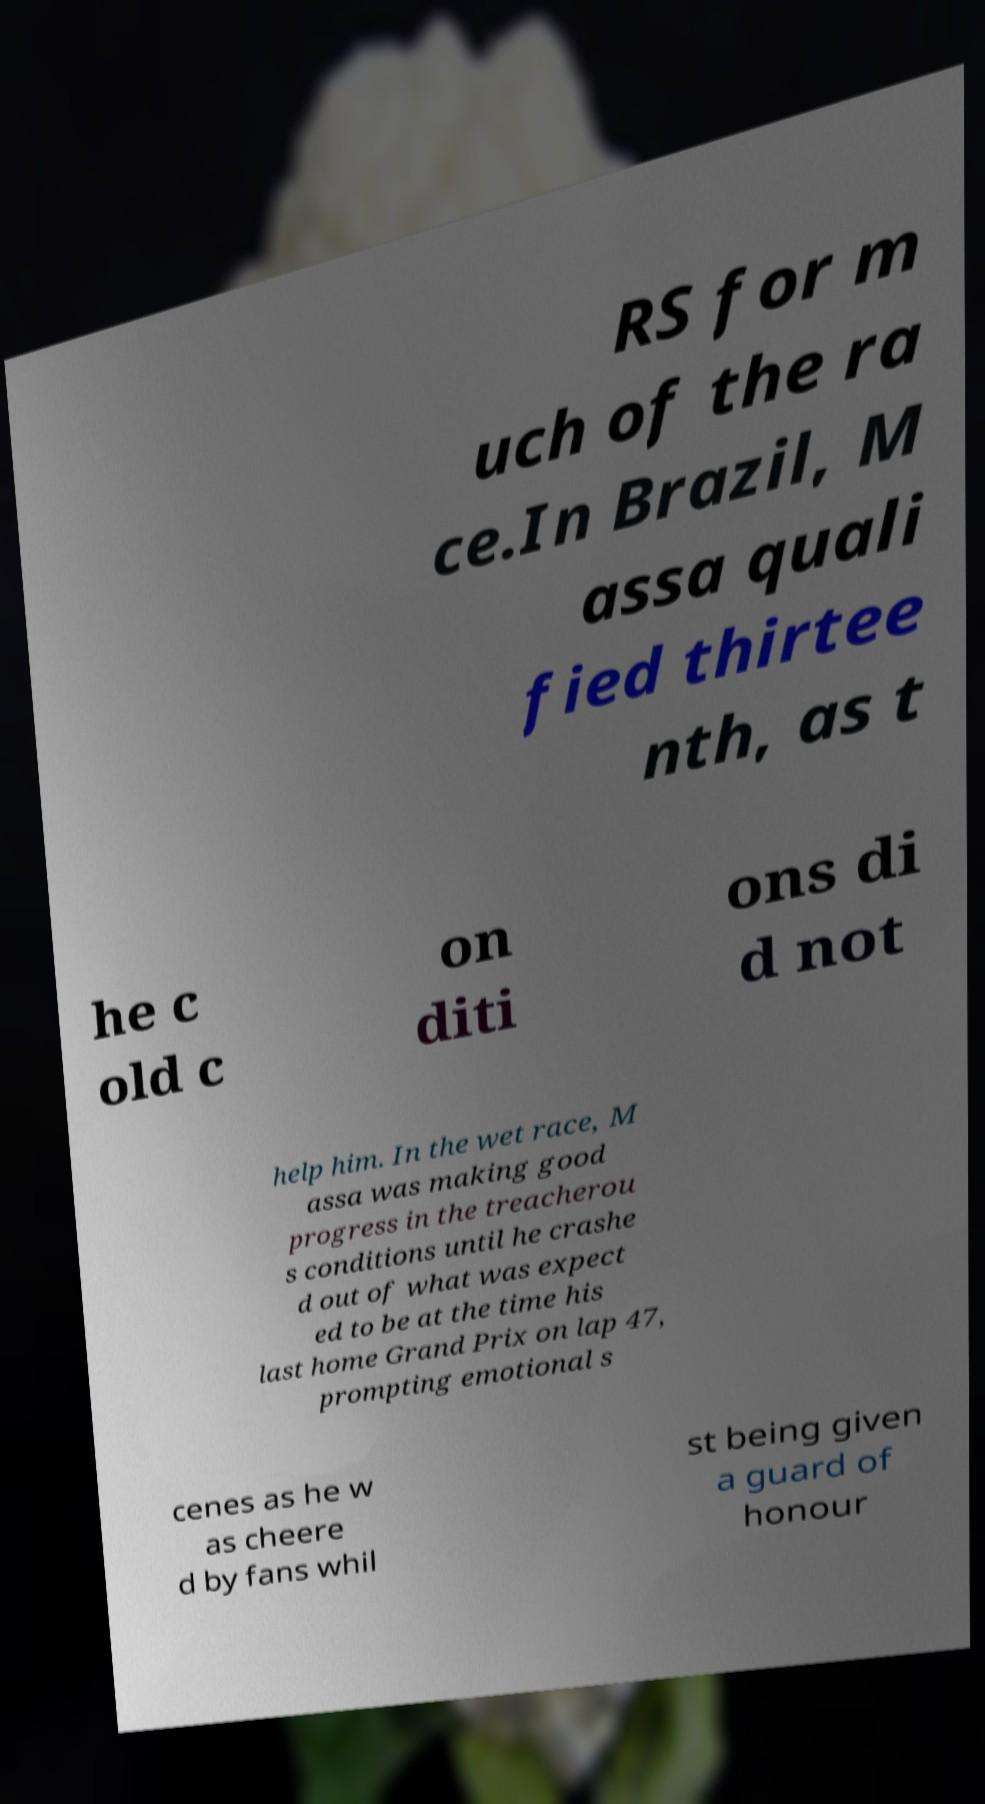For documentation purposes, I need the text within this image transcribed. Could you provide that? RS for m uch of the ra ce.In Brazil, M assa quali fied thirtee nth, as t he c old c on diti ons di d not help him. In the wet race, M assa was making good progress in the treacherou s conditions until he crashe d out of what was expect ed to be at the time his last home Grand Prix on lap 47, prompting emotional s cenes as he w as cheere d by fans whil st being given a guard of honour 